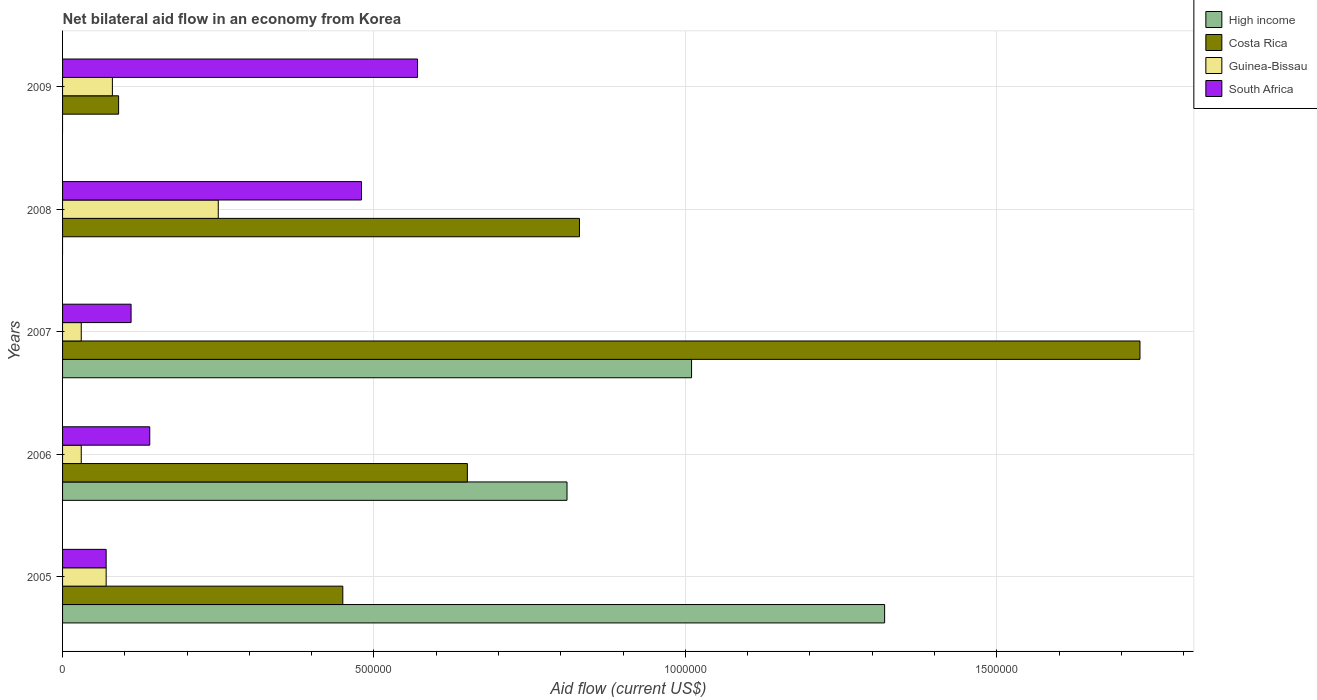How many different coloured bars are there?
Ensure brevity in your answer.  4. Are the number of bars per tick equal to the number of legend labels?
Offer a very short reply. No. Are the number of bars on each tick of the Y-axis equal?
Your response must be concise. No. How many bars are there on the 1st tick from the top?
Your answer should be compact. 3. How many bars are there on the 3rd tick from the bottom?
Keep it short and to the point. 4. What is the net bilateral aid flow in Costa Rica in 2007?
Your response must be concise. 1.73e+06. In which year was the net bilateral aid flow in Costa Rica maximum?
Ensure brevity in your answer.  2007. What is the total net bilateral aid flow in Costa Rica in the graph?
Offer a very short reply. 3.75e+06. What is the difference between the net bilateral aid flow in South Africa in 2006 and the net bilateral aid flow in Costa Rica in 2008?
Your answer should be compact. -6.90e+05. What is the average net bilateral aid flow in South Africa per year?
Your answer should be very brief. 2.74e+05. In the year 2005, what is the difference between the net bilateral aid flow in Guinea-Bissau and net bilateral aid flow in Costa Rica?
Make the answer very short. -3.80e+05. In how many years, is the net bilateral aid flow in Guinea-Bissau greater than 100000 US$?
Provide a succinct answer. 1. Is the net bilateral aid flow in South Africa in 2006 less than that in 2007?
Your response must be concise. No. Is the difference between the net bilateral aid flow in Guinea-Bissau in 2007 and 2009 greater than the difference between the net bilateral aid flow in Costa Rica in 2007 and 2009?
Keep it short and to the point. No. What is the difference between the highest and the second highest net bilateral aid flow in Costa Rica?
Your response must be concise. 9.00e+05. Are all the bars in the graph horizontal?
Provide a short and direct response. Yes. Are the values on the major ticks of X-axis written in scientific E-notation?
Make the answer very short. No. Does the graph contain grids?
Your answer should be compact. Yes. Where does the legend appear in the graph?
Provide a succinct answer. Top right. How many legend labels are there?
Provide a short and direct response. 4. What is the title of the graph?
Provide a succinct answer. Net bilateral aid flow in an economy from Korea. Does "Mongolia" appear as one of the legend labels in the graph?
Give a very brief answer. No. What is the label or title of the X-axis?
Your answer should be compact. Aid flow (current US$). What is the Aid flow (current US$) in High income in 2005?
Provide a succinct answer. 1.32e+06. What is the Aid flow (current US$) of Guinea-Bissau in 2005?
Offer a terse response. 7.00e+04. What is the Aid flow (current US$) of South Africa in 2005?
Offer a terse response. 7.00e+04. What is the Aid flow (current US$) in High income in 2006?
Ensure brevity in your answer.  8.10e+05. What is the Aid flow (current US$) of Costa Rica in 2006?
Offer a very short reply. 6.50e+05. What is the Aid flow (current US$) of Guinea-Bissau in 2006?
Keep it short and to the point. 3.00e+04. What is the Aid flow (current US$) in High income in 2007?
Keep it short and to the point. 1.01e+06. What is the Aid flow (current US$) in Costa Rica in 2007?
Give a very brief answer. 1.73e+06. What is the Aid flow (current US$) in Guinea-Bissau in 2007?
Your answer should be very brief. 3.00e+04. What is the Aid flow (current US$) of South Africa in 2007?
Provide a succinct answer. 1.10e+05. What is the Aid flow (current US$) in High income in 2008?
Make the answer very short. 0. What is the Aid flow (current US$) of Costa Rica in 2008?
Your answer should be very brief. 8.30e+05. What is the Aid flow (current US$) in South Africa in 2008?
Offer a terse response. 4.80e+05. What is the Aid flow (current US$) in High income in 2009?
Ensure brevity in your answer.  0. What is the Aid flow (current US$) in Costa Rica in 2009?
Provide a succinct answer. 9.00e+04. What is the Aid flow (current US$) of South Africa in 2009?
Offer a very short reply. 5.70e+05. Across all years, what is the maximum Aid flow (current US$) in High income?
Offer a very short reply. 1.32e+06. Across all years, what is the maximum Aid flow (current US$) in Costa Rica?
Provide a short and direct response. 1.73e+06. Across all years, what is the maximum Aid flow (current US$) of South Africa?
Provide a succinct answer. 5.70e+05. Across all years, what is the minimum Aid flow (current US$) in Costa Rica?
Offer a terse response. 9.00e+04. Across all years, what is the minimum Aid flow (current US$) of Guinea-Bissau?
Make the answer very short. 3.00e+04. What is the total Aid flow (current US$) of High income in the graph?
Offer a very short reply. 3.14e+06. What is the total Aid flow (current US$) of Costa Rica in the graph?
Your response must be concise. 3.75e+06. What is the total Aid flow (current US$) in Guinea-Bissau in the graph?
Your response must be concise. 4.60e+05. What is the total Aid flow (current US$) of South Africa in the graph?
Your answer should be compact. 1.37e+06. What is the difference between the Aid flow (current US$) of High income in 2005 and that in 2006?
Offer a terse response. 5.10e+05. What is the difference between the Aid flow (current US$) of Costa Rica in 2005 and that in 2006?
Provide a short and direct response. -2.00e+05. What is the difference between the Aid flow (current US$) of Guinea-Bissau in 2005 and that in 2006?
Offer a terse response. 4.00e+04. What is the difference between the Aid flow (current US$) of South Africa in 2005 and that in 2006?
Give a very brief answer. -7.00e+04. What is the difference between the Aid flow (current US$) of High income in 2005 and that in 2007?
Provide a short and direct response. 3.10e+05. What is the difference between the Aid flow (current US$) of Costa Rica in 2005 and that in 2007?
Offer a very short reply. -1.28e+06. What is the difference between the Aid flow (current US$) of South Africa in 2005 and that in 2007?
Your answer should be very brief. -4.00e+04. What is the difference between the Aid flow (current US$) in Costa Rica in 2005 and that in 2008?
Provide a succinct answer. -3.80e+05. What is the difference between the Aid flow (current US$) of Guinea-Bissau in 2005 and that in 2008?
Offer a very short reply. -1.80e+05. What is the difference between the Aid flow (current US$) in South Africa in 2005 and that in 2008?
Provide a succinct answer. -4.10e+05. What is the difference between the Aid flow (current US$) of Costa Rica in 2005 and that in 2009?
Give a very brief answer. 3.60e+05. What is the difference between the Aid flow (current US$) of South Africa in 2005 and that in 2009?
Provide a short and direct response. -5.00e+05. What is the difference between the Aid flow (current US$) of Costa Rica in 2006 and that in 2007?
Give a very brief answer. -1.08e+06. What is the difference between the Aid flow (current US$) in Guinea-Bissau in 2006 and that in 2007?
Offer a very short reply. 0. What is the difference between the Aid flow (current US$) of South Africa in 2006 and that in 2008?
Your response must be concise. -3.40e+05. What is the difference between the Aid flow (current US$) in Costa Rica in 2006 and that in 2009?
Give a very brief answer. 5.60e+05. What is the difference between the Aid flow (current US$) in Guinea-Bissau in 2006 and that in 2009?
Give a very brief answer. -5.00e+04. What is the difference between the Aid flow (current US$) in South Africa in 2006 and that in 2009?
Your answer should be compact. -4.30e+05. What is the difference between the Aid flow (current US$) of Costa Rica in 2007 and that in 2008?
Your answer should be compact. 9.00e+05. What is the difference between the Aid flow (current US$) in South Africa in 2007 and that in 2008?
Make the answer very short. -3.70e+05. What is the difference between the Aid flow (current US$) in Costa Rica in 2007 and that in 2009?
Give a very brief answer. 1.64e+06. What is the difference between the Aid flow (current US$) in South Africa in 2007 and that in 2009?
Provide a short and direct response. -4.60e+05. What is the difference between the Aid flow (current US$) of Costa Rica in 2008 and that in 2009?
Your answer should be compact. 7.40e+05. What is the difference between the Aid flow (current US$) of Guinea-Bissau in 2008 and that in 2009?
Ensure brevity in your answer.  1.70e+05. What is the difference between the Aid flow (current US$) in High income in 2005 and the Aid flow (current US$) in Costa Rica in 2006?
Keep it short and to the point. 6.70e+05. What is the difference between the Aid flow (current US$) in High income in 2005 and the Aid flow (current US$) in Guinea-Bissau in 2006?
Provide a short and direct response. 1.29e+06. What is the difference between the Aid flow (current US$) of High income in 2005 and the Aid flow (current US$) of South Africa in 2006?
Offer a very short reply. 1.18e+06. What is the difference between the Aid flow (current US$) in Costa Rica in 2005 and the Aid flow (current US$) in Guinea-Bissau in 2006?
Offer a very short reply. 4.20e+05. What is the difference between the Aid flow (current US$) of High income in 2005 and the Aid flow (current US$) of Costa Rica in 2007?
Ensure brevity in your answer.  -4.10e+05. What is the difference between the Aid flow (current US$) of High income in 2005 and the Aid flow (current US$) of Guinea-Bissau in 2007?
Your answer should be very brief. 1.29e+06. What is the difference between the Aid flow (current US$) of High income in 2005 and the Aid flow (current US$) of South Africa in 2007?
Your response must be concise. 1.21e+06. What is the difference between the Aid flow (current US$) in Costa Rica in 2005 and the Aid flow (current US$) in Guinea-Bissau in 2007?
Provide a succinct answer. 4.20e+05. What is the difference between the Aid flow (current US$) in Costa Rica in 2005 and the Aid flow (current US$) in South Africa in 2007?
Offer a terse response. 3.40e+05. What is the difference between the Aid flow (current US$) in Guinea-Bissau in 2005 and the Aid flow (current US$) in South Africa in 2007?
Provide a succinct answer. -4.00e+04. What is the difference between the Aid flow (current US$) of High income in 2005 and the Aid flow (current US$) of Costa Rica in 2008?
Give a very brief answer. 4.90e+05. What is the difference between the Aid flow (current US$) in High income in 2005 and the Aid flow (current US$) in Guinea-Bissau in 2008?
Provide a succinct answer. 1.07e+06. What is the difference between the Aid flow (current US$) of High income in 2005 and the Aid flow (current US$) of South Africa in 2008?
Your answer should be very brief. 8.40e+05. What is the difference between the Aid flow (current US$) in Costa Rica in 2005 and the Aid flow (current US$) in Guinea-Bissau in 2008?
Make the answer very short. 2.00e+05. What is the difference between the Aid flow (current US$) in Costa Rica in 2005 and the Aid flow (current US$) in South Africa in 2008?
Provide a short and direct response. -3.00e+04. What is the difference between the Aid flow (current US$) of Guinea-Bissau in 2005 and the Aid flow (current US$) of South Africa in 2008?
Offer a very short reply. -4.10e+05. What is the difference between the Aid flow (current US$) of High income in 2005 and the Aid flow (current US$) of Costa Rica in 2009?
Ensure brevity in your answer.  1.23e+06. What is the difference between the Aid flow (current US$) of High income in 2005 and the Aid flow (current US$) of Guinea-Bissau in 2009?
Make the answer very short. 1.24e+06. What is the difference between the Aid flow (current US$) of High income in 2005 and the Aid flow (current US$) of South Africa in 2009?
Offer a very short reply. 7.50e+05. What is the difference between the Aid flow (current US$) of Guinea-Bissau in 2005 and the Aid flow (current US$) of South Africa in 2009?
Your answer should be compact. -5.00e+05. What is the difference between the Aid flow (current US$) in High income in 2006 and the Aid flow (current US$) in Costa Rica in 2007?
Your response must be concise. -9.20e+05. What is the difference between the Aid flow (current US$) in High income in 2006 and the Aid flow (current US$) in Guinea-Bissau in 2007?
Your answer should be compact. 7.80e+05. What is the difference between the Aid flow (current US$) of High income in 2006 and the Aid flow (current US$) of South Africa in 2007?
Offer a terse response. 7.00e+05. What is the difference between the Aid flow (current US$) of Costa Rica in 2006 and the Aid flow (current US$) of Guinea-Bissau in 2007?
Your response must be concise. 6.20e+05. What is the difference between the Aid flow (current US$) of Costa Rica in 2006 and the Aid flow (current US$) of South Africa in 2007?
Your answer should be compact. 5.40e+05. What is the difference between the Aid flow (current US$) in Guinea-Bissau in 2006 and the Aid flow (current US$) in South Africa in 2007?
Provide a succinct answer. -8.00e+04. What is the difference between the Aid flow (current US$) of High income in 2006 and the Aid flow (current US$) of Guinea-Bissau in 2008?
Provide a short and direct response. 5.60e+05. What is the difference between the Aid flow (current US$) of Costa Rica in 2006 and the Aid flow (current US$) of Guinea-Bissau in 2008?
Offer a very short reply. 4.00e+05. What is the difference between the Aid flow (current US$) in Guinea-Bissau in 2006 and the Aid flow (current US$) in South Africa in 2008?
Offer a very short reply. -4.50e+05. What is the difference between the Aid flow (current US$) of High income in 2006 and the Aid flow (current US$) of Costa Rica in 2009?
Offer a terse response. 7.20e+05. What is the difference between the Aid flow (current US$) of High income in 2006 and the Aid flow (current US$) of Guinea-Bissau in 2009?
Your response must be concise. 7.30e+05. What is the difference between the Aid flow (current US$) of Costa Rica in 2006 and the Aid flow (current US$) of Guinea-Bissau in 2009?
Provide a short and direct response. 5.70e+05. What is the difference between the Aid flow (current US$) of Costa Rica in 2006 and the Aid flow (current US$) of South Africa in 2009?
Provide a short and direct response. 8.00e+04. What is the difference between the Aid flow (current US$) in Guinea-Bissau in 2006 and the Aid flow (current US$) in South Africa in 2009?
Your answer should be compact. -5.40e+05. What is the difference between the Aid flow (current US$) of High income in 2007 and the Aid flow (current US$) of Guinea-Bissau in 2008?
Offer a very short reply. 7.60e+05. What is the difference between the Aid flow (current US$) of High income in 2007 and the Aid flow (current US$) of South Africa in 2008?
Ensure brevity in your answer.  5.30e+05. What is the difference between the Aid flow (current US$) in Costa Rica in 2007 and the Aid flow (current US$) in Guinea-Bissau in 2008?
Your answer should be very brief. 1.48e+06. What is the difference between the Aid flow (current US$) of Costa Rica in 2007 and the Aid flow (current US$) of South Africa in 2008?
Ensure brevity in your answer.  1.25e+06. What is the difference between the Aid flow (current US$) in Guinea-Bissau in 2007 and the Aid flow (current US$) in South Africa in 2008?
Offer a terse response. -4.50e+05. What is the difference between the Aid flow (current US$) of High income in 2007 and the Aid flow (current US$) of Costa Rica in 2009?
Your answer should be compact. 9.20e+05. What is the difference between the Aid flow (current US$) in High income in 2007 and the Aid flow (current US$) in Guinea-Bissau in 2009?
Offer a terse response. 9.30e+05. What is the difference between the Aid flow (current US$) of Costa Rica in 2007 and the Aid flow (current US$) of Guinea-Bissau in 2009?
Offer a terse response. 1.65e+06. What is the difference between the Aid flow (current US$) in Costa Rica in 2007 and the Aid flow (current US$) in South Africa in 2009?
Make the answer very short. 1.16e+06. What is the difference between the Aid flow (current US$) of Guinea-Bissau in 2007 and the Aid flow (current US$) of South Africa in 2009?
Keep it short and to the point. -5.40e+05. What is the difference between the Aid flow (current US$) in Costa Rica in 2008 and the Aid flow (current US$) in Guinea-Bissau in 2009?
Keep it short and to the point. 7.50e+05. What is the difference between the Aid flow (current US$) in Guinea-Bissau in 2008 and the Aid flow (current US$) in South Africa in 2009?
Your answer should be very brief. -3.20e+05. What is the average Aid flow (current US$) of High income per year?
Make the answer very short. 6.28e+05. What is the average Aid flow (current US$) of Costa Rica per year?
Provide a succinct answer. 7.50e+05. What is the average Aid flow (current US$) in Guinea-Bissau per year?
Offer a terse response. 9.20e+04. What is the average Aid flow (current US$) of South Africa per year?
Ensure brevity in your answer.  2.74e+05. In the year 2005, what is the difference between the Aid flow (current US$) in High income and Aid flow (current US$) in Costa Rica?
Your answer should be compact. 8.70e+05. In the year 2005, what is the difference between the Aid flow (current US$) in High income and Aid flow (current US$) in Guinea-Bissau?
Your answer should be very brief. 1.25e+06. In the year 2005, what is the difference between the Aid flow (current US$) in High income and Aid flow (current US$) in South Africa?
Your response must be concise. 1.25e+06. In the year 2005, what is the difference between the Aid flow (current US$) in Costa Rica and Aid flow (current US$) in Guinea-Bissau?
Provide a short and direct response. 3.80e+05. In the year 2005, what is the difference between the Aid flow (current US$) of Costa Rica and Aid flow (current US$) of South Africa?
Offer a terse response. 3.80e+05. In the year 2005, what is the difference between the Aid flow (current US$) of Guinea-Bissau and Aid flow (current US$) of South Africa?
Offer a very short reply. 0. In the year 2006, what is the difference between the Aid flow (current US$) in High income and Aid flow (current US$) in Guinea-Bissau?
Offer a terse response. 7.80e+05. In the year 2006, what is the difference between the Aid flow (current US$) in High income and Aid flow (current US$) in South Africa?
Give a very brief answer. 6.70e+05. In the year 2006, what is the difference between the Aid flow (current US$) of Costa Rica and Aid flow (current US$) of Guinea-Bissau?
Your response must be concise. 6.20e+05. In the year 2006, what is the difference between the Aid flow (current US$) of Costa Rica and Aid flow (current US$) of South Africa?
Give a very brief answer. 5.10e+05. In the year 2007, what is the difference between the Aid flow (current US$) in High income and Aid flow (current US$) in Costa Rica?
Keep it short and to the point. -7.20e+05. In the year 2007, what is the difference between the Aid flow (current US$) of High income and Aid flow (current US$) of Guinea-Bissau?
Your response must be concise. 9.80e+05. In the year 2007, what is the difference between the Aid flow (current US$) in Costa Rica and Aid flow (current US$) in Guinea-Bissau?
Provide a short and direct response. 1.70e+06. In the year 2007, what is the difference between the Aid flow (current US$) of Costa Rica and Aid flow (current US$) of South Africa?
Make the answer very short. 1.62e+06. In the year 2007, what is the difference between the Aid flow (current US$) in Guinea-Bissau and Aid flow (current US$) in South Africa?
Your response must be concise. -8.00e+04. In the year 2008, what is the difference between the Aid flow (current US$) of Costa Rica and Aid flow (current US$) of Guinea-Bissau?
Provide a short and direct response. 5.80e+05. In the year 2008, what is the difference between the Aid flow (current US$) in Costa Rica and Aid flow (current US$) in South Africa?
Ensure brevity in your answer.  3.50e+05. In the year 2008, what is the difference between the Aid flow (current US$) of Guinea-Bissau and Aid flow (current US$) of South Africa?
Keep it short and to the point. -2.30e+05. In the year 2009, what is the difference between the Aid flow (current US$) in Costa Rica and Aid flow (current US$) in South Africa?
Make the answer very short. -4.80e+05. In the year 2009, what is the difference between the Aid flow (current US$) in Guinea-Bissau and Aid flow (current US$) in South Africa?
Provide a succinct answer. -4.90e+05. What is the ratio of the Aid flow (current US$) of High income in 2005 to that in 2006?
Offer a terse response. 1.63. What is the ratio of the Aid flow (current US$) of Costa Rica in 2005 to that in 2006?
Make the answer very short. 0.69. What is the ratio of the Aid flow (current US$) in Guinea-Bissau in 2005 to that in 2006?
Your answer should be compact. 2.33. What is the ratio of the Aid flow (current US$) of South Africa in 2005 to that in 2006?
Offer a terse response. 0.5. What is the ratio of the Aid flow (current US$) in High income in 2005 to that in 2007?
Give a very brief answer. 1.31. What is the ratio of the Aid flow (current US$) of Costa Rica in 2005 to that in 2007?
Make the answer very short. 0.26. What is the ratio of the Aid flow (current US$) in Guinea-Bissau in 2005 to that in 2007?
Your answer should be very brief. 2.33. What is the ratio of the Aid flow (current US$) of South Africa in 2005 to that in 2007?
Give a very brief answer. 0.64. What is the ratio of the Aid flow (current US$) of Costa Rica in 2005 to that in 2008?
Offer a very short reply. 0.54. What is the ratio of the Aid flow (current US$) in Guinea-Bissau in 2005 to that in 2008?
Make the answer very short. 0.28. What is the ratio of the Aid flow (current US$) in South Africa in 2005 to that in 2008?
Give a very brief answer. 0.15. What is the ratio of the Aid flow (current US$) in Guinea-Bissau in 2005 to that in 2009?
Offer a very short reply. 0.88. What is the ratio of the Aid flow (current US$) in South Africa in 2005 to that in 2009?
Your answer should be very brief. 0.12. What is the ratio of the Aid flow (current US$) of High income in 2006 to that in 2007?
Ensure brevity in your answer.  0.8. What is the ratio of the Aid flow (current US$) of Costa Rica in 2006 to that in 2007?
Keep it short and to the point. 0.38. What is the ratio of the Aid flow (current US$) in Guinea-Bissau in 2006 to that in 2007?
Provide a succinct answer. 1. What is the ratio of the Aid flow (current US$) in South Africa in 2006 to that in 2007?
Offer a very short reply. 1.27. What is the ratio of the Aid flow (current US$) of Costa Rica in 2006 to that in 2008?
Offer a terse response. 0.78. What is the ratio of the Aid flow (current US$) of Guinea-Bissau in 2006 to that in 2008?
Ensure brevity in your answer.  0.12. What is the ratio of the Aid flow (current US$) in South Africa in 2006 to that in 2008?
Keep it short and to the point. 0.29. What is the ratio of the Aid flow (current US$) in Costa Rica in 2006 to that in 2009?
Offer a very short reply. 7.22. What is the ratio of the Aid flow (current US$) of South Africa in 2006 to that in 2009?
Offer a terse response. 0.25. What is the ratio of the Aid flow (current US$) in Costa Rica in 2007 to that in 2008?
Offer a terse response. 2.08. What is the ratio of the Aid flow (current US$) of Guinea-Bissau in 2007 to that in 2008?
Offer a very short reply. 0.12. What is the ratio of the Aid flow (current US$) in South Africa in 2007 to that in 2008?
Offer a terse response. 0.23. What is the ratio of the Aid flow (current US$) of Costa Rica in 2007 to that in 2009?
Make the answer very short. 19.22. What is the ratio of the Aid flow (current US$) in South Africa in 2007 to that in 2009?
Offer a very short reply. 0.19. What is the ratio of the Aid flow (current US$) of Costa Rica in 2008 to that in 2009?
Your answer should be very brief. 9.22. What is the ratio of the Aid flow (current US$) of Guinea-Bissau in 2008 to that in 2009?
Offer a terse response. 3.12. What is the ratio of the Aid flow (current US$) in South Africa in 2008 to that in 2009?
Offer a very short reply. 0.84. What is the difference between the highest and the second highest Aid flow (current US$) in High income?
Give a very brief answer. 3.10e+05. What is the difference between the highest and the lowest Aid flow (current US$) in High income?
Your answer should be very brief. 1.32e+06. What is the difference between the highest and the lowest Aid flow (current US$) of Costa Rica?
Offer a terse response. 1.64e+06. What is the difference between the highest and the lowest Aid flow (current US$) of Guinea-Bissau?
Your answer should be compact. 2.20e+05. 